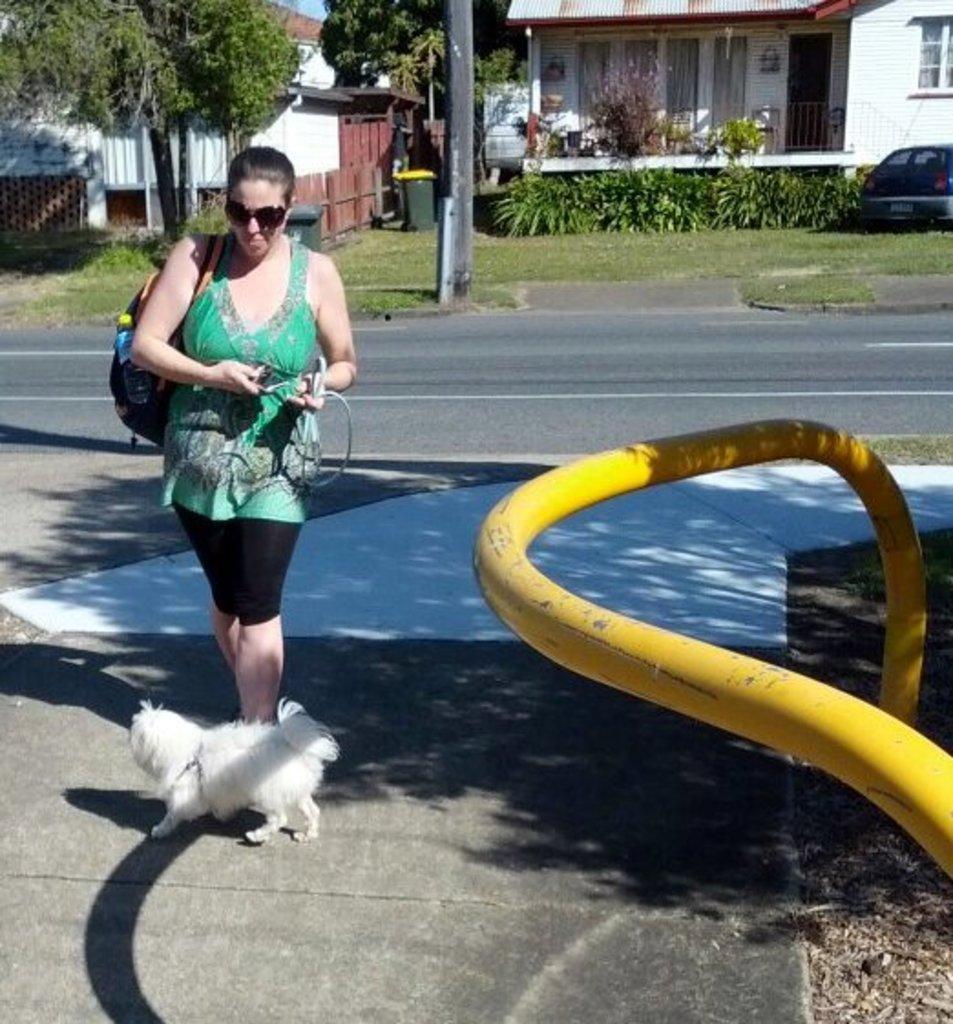How would you summarize this image in a sentence or two? In this picture we can see a woman wore goggles, carrying a bag and in front of her we can see a dog on the path and at the back of her we can see the road, grass, vehicle, dustbin, plants, trees, buildings and some objects. 